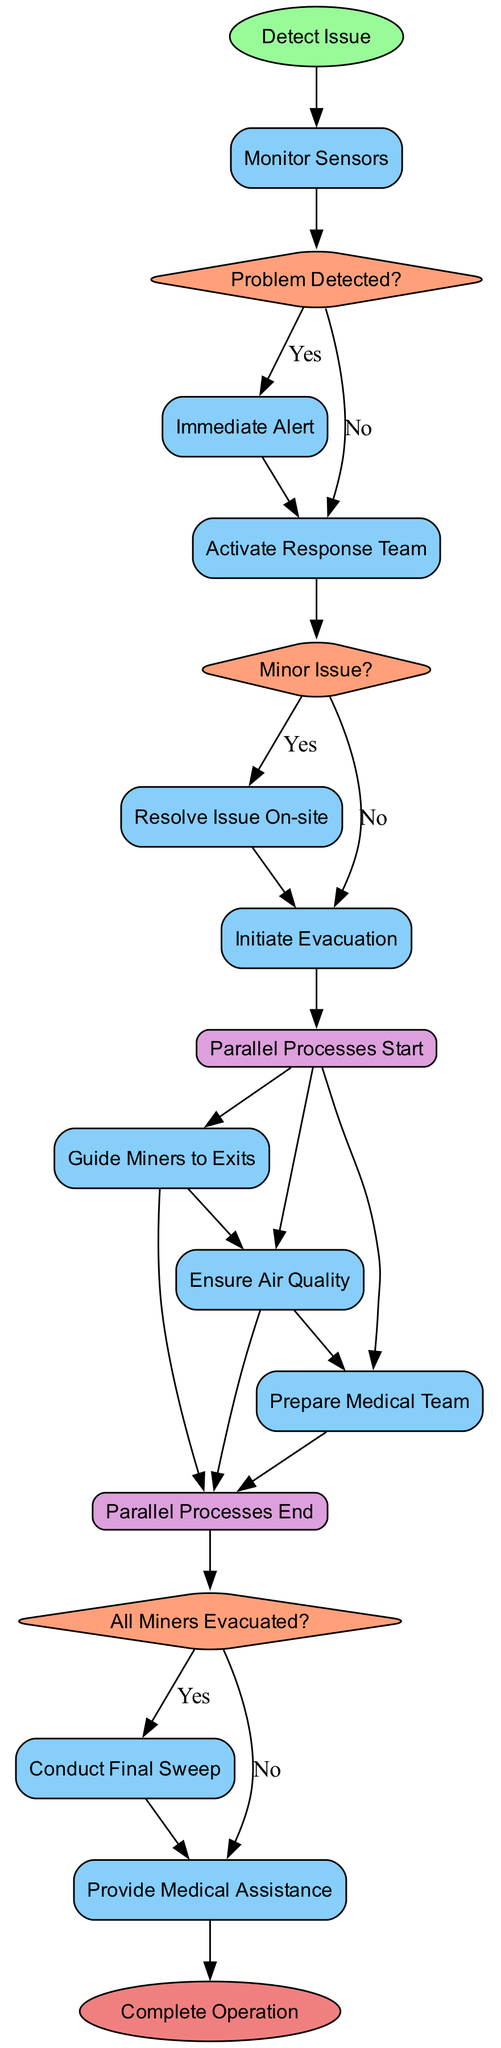What is the first action in the diagram? The first action is "Monitor Sensors," which follows the "Detect Issue" start node. It involves continuous monitoring of conditions in the mine.
Answer: Monitor Sensors How many total actions are specified in the diagram? By counting the actions listed, there are a total of six actions present in the diagram.
Answer: Six What happens if a problem is detected? If a problem is detected, the next action is to "Immediate Alert," which triggers alarms and broadcasts messages to miners.
Answer: Immediate Alert If the problem is minor, what subsequent action occurs? If the problem is minor, the emergency response team will take the "Resolve Issue On-site" action to address the concern without needing evacuation.
Answer: Resolve Issue On-site What process starts after the evacuation is initiated? After the evacuation is initiated, the "Guide Miners to Exits" action starts as part of the parallel processes for safely directing miners.
Answer: Guide Miners to Exits What must happen before declaring the operation complete? Before declaring "Complete Operation," it is necessary to confirm through the "All Miners Evacuated?" decision that all miners have been safely evacuated from the mine.
Answer: All Miners Evacuated? What are the two parallel processes that occur during evacuation? The two parallel processes during evacuation are "Guide Miners to Exits" and "Ensure Air Quality," which run simultaneously.
Answer: Guide Miners to Exits and Ensure Air Quality What does the emergency team do after ensuring all miners are evacuated? After ensuring that all miners are evacuated, the emergency team will conduct a "Conduct Final Sweep" to ensure there are no remaining miners in the mine.
Answer: Conduct Final Sweep 